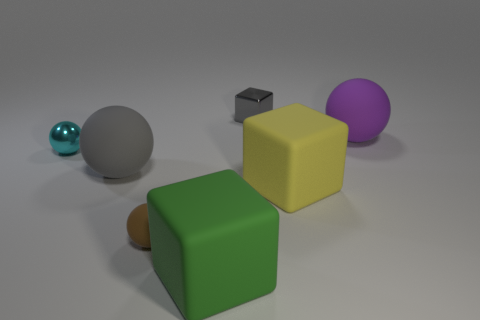Subtract all rubber blocks. How many blocks are left? 1 Add 1 tiny purple matte cylinders. How many objects exist? 8 Subtract all purple spheres. How many spheres are left? 3 Subtract 2 cubes. How many cubes are left? 1 Subtract all tiny gray objects. Subtract all gray things. How many objects are left? 4 Add 2 tiny gray metallic objects. How many tiny gray metallic objects are left? 3 Add 7 gray metallic blocks. How many gray metallic blocks exist? 8 Subtract 0 brown cylinders. How many objects are left? 7 Subtract all spheres. How many objects are left? 3 Subtract all yellow balls. Subtract all blue cylinders. How many balls are left? 4 